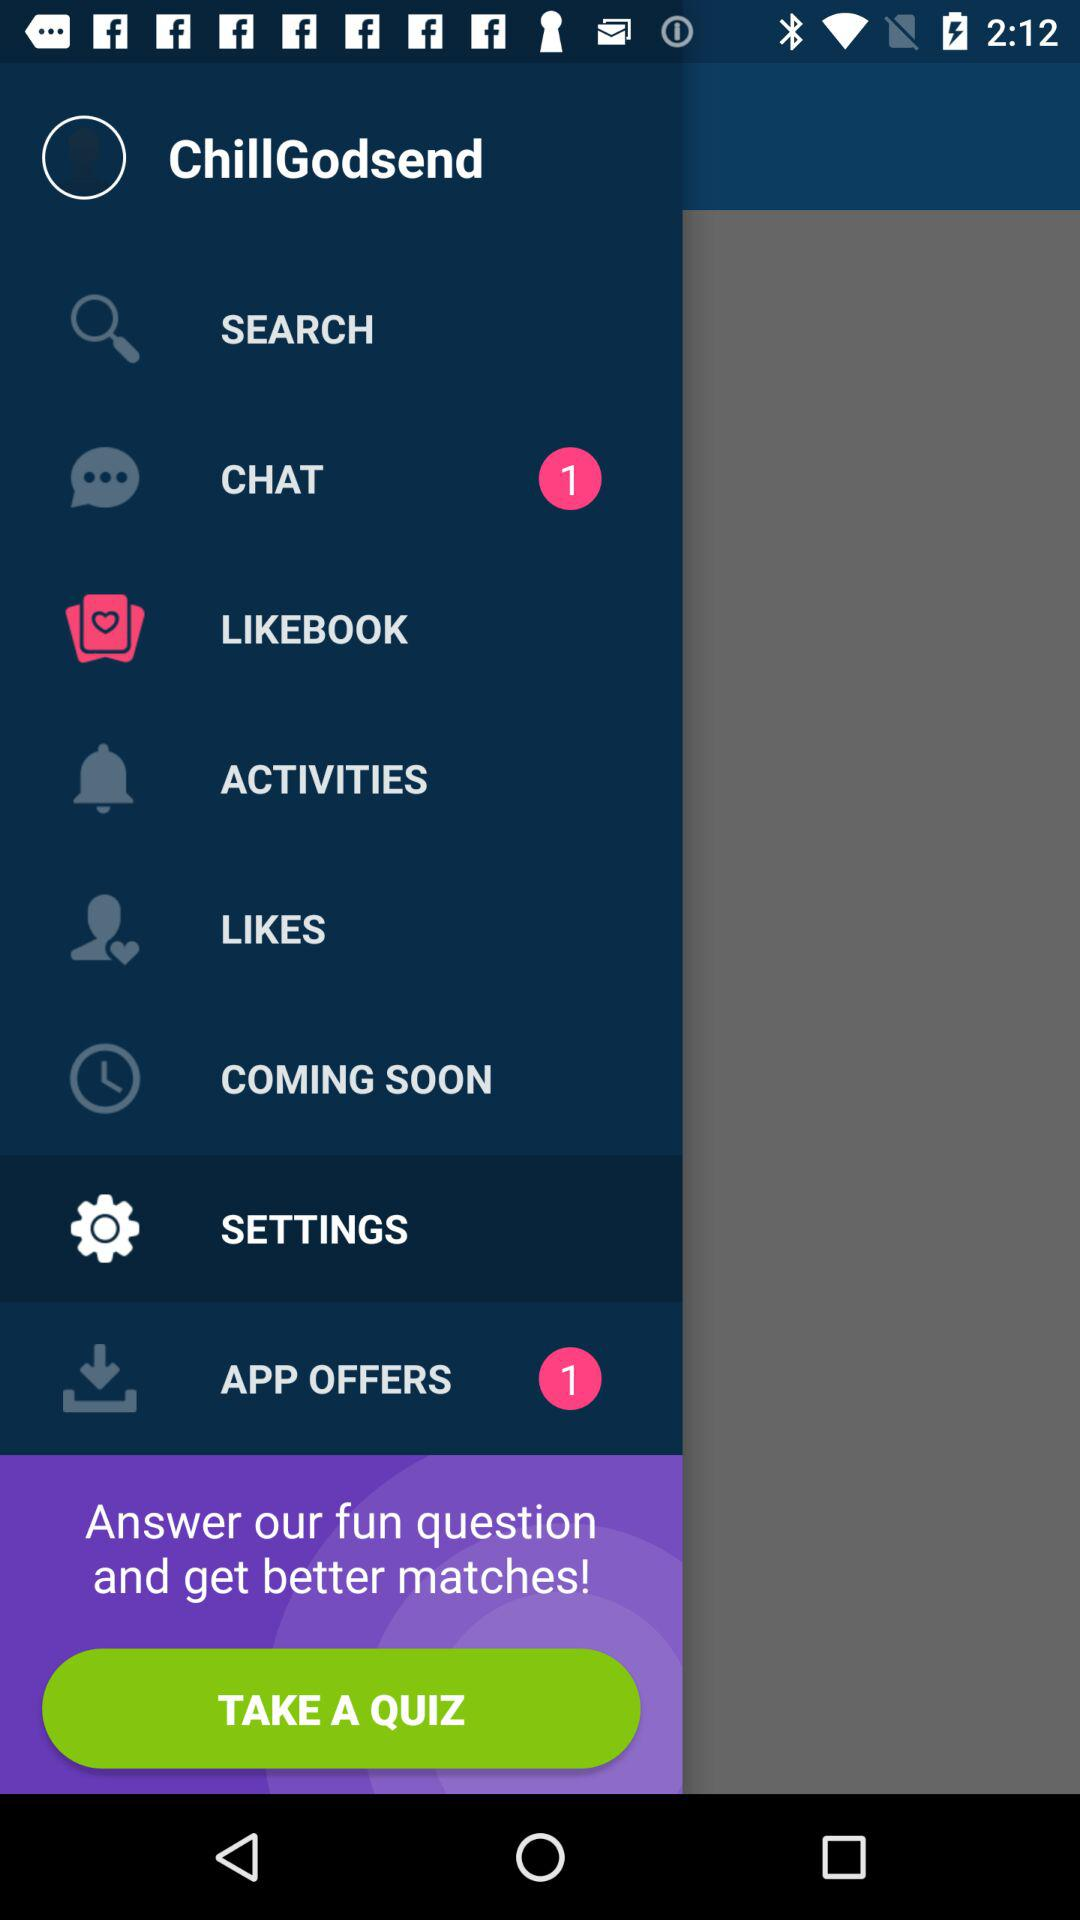How many notifications are in the "APP OFFERS" section? There is 1 notification. 